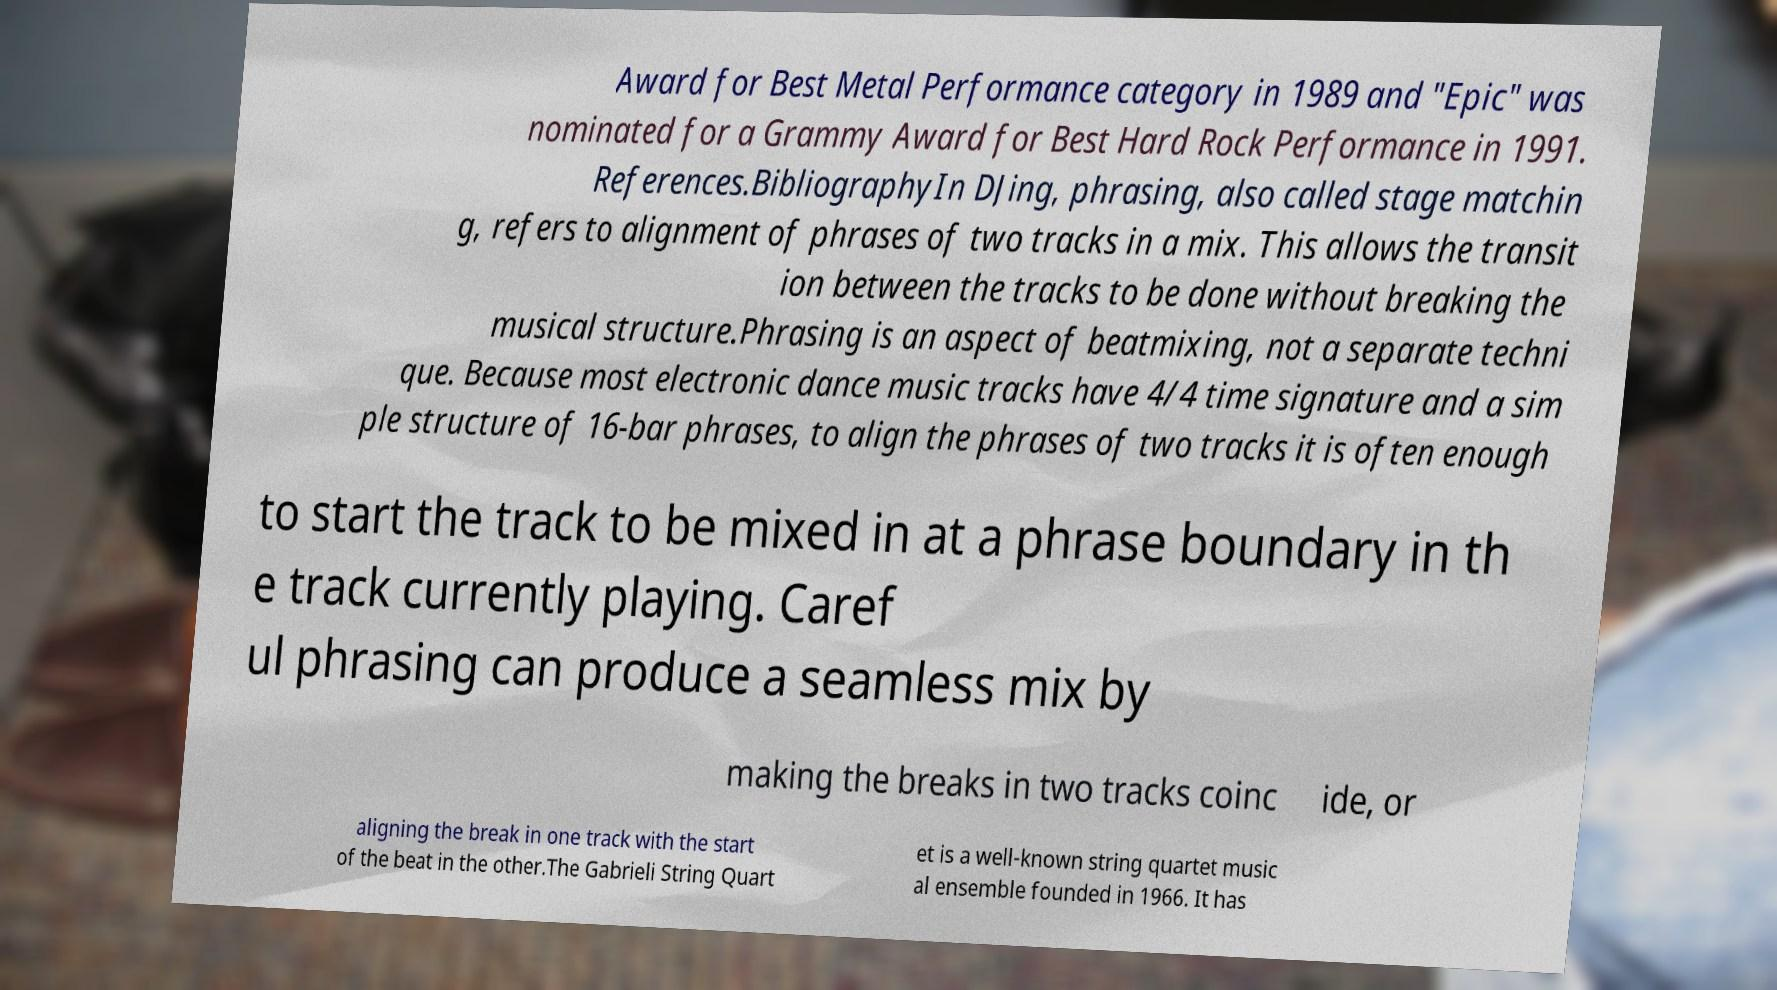Please identify and transcribe the text found in this image. Award for Best Metal Performance category in 1989 and "Epic" was nominated for a Grammy Award for Best Hard Rock Performance in 1991. References.BibliographyIn DJing, phrasing, also called stage matchin g, refers to alignment of phrases of two tracks in a mix. This allows the transit ion between the tracks to be done without breaking the musical structure.Phrasing is an aspect of beatmixing, not a separate techni que. Because most electronic dance music tracks have 4/4 time signature and a sim ple structure of 16-bar phrases, to align the phrases of two tracks it is often enough to start the track to be mixed in at a phrase boundary in th e track currently playing. Caref ul phrasing can produce a seamless mix by making the breaks in two tracks coinc ide, or aligning the break in one track with the start of the beat in the other.The Gabrieli String Quart et is a well-known string quartet music al ensemble founded in 1966. It has 